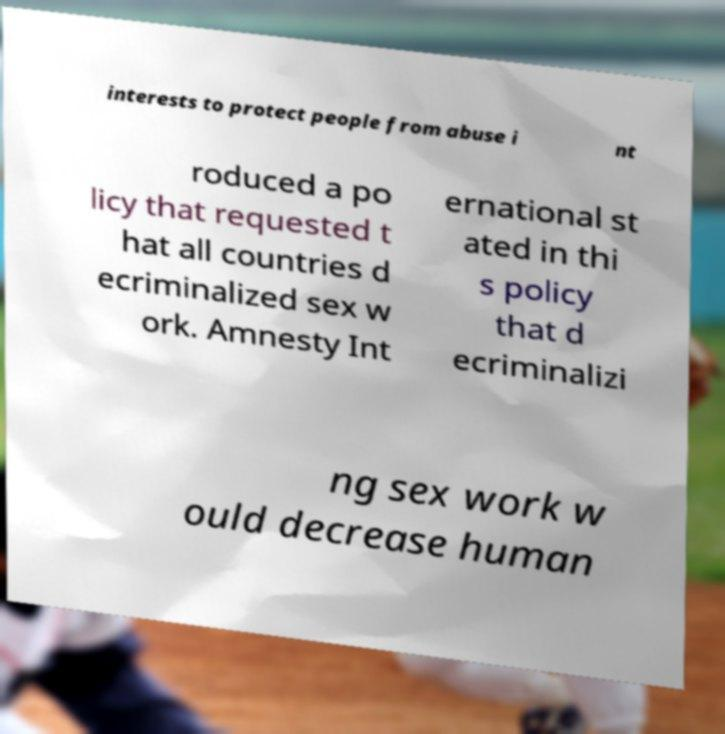Please read and relay the text visible in this image. What does it say? interests to protect people from abuse i nt roduced a po licy that requested t hat all countries d ecriminalized sex w ork. Amnesty Int ernational st ated in thi s policy that d ecriminalizi ng sex work w ould decrease human 